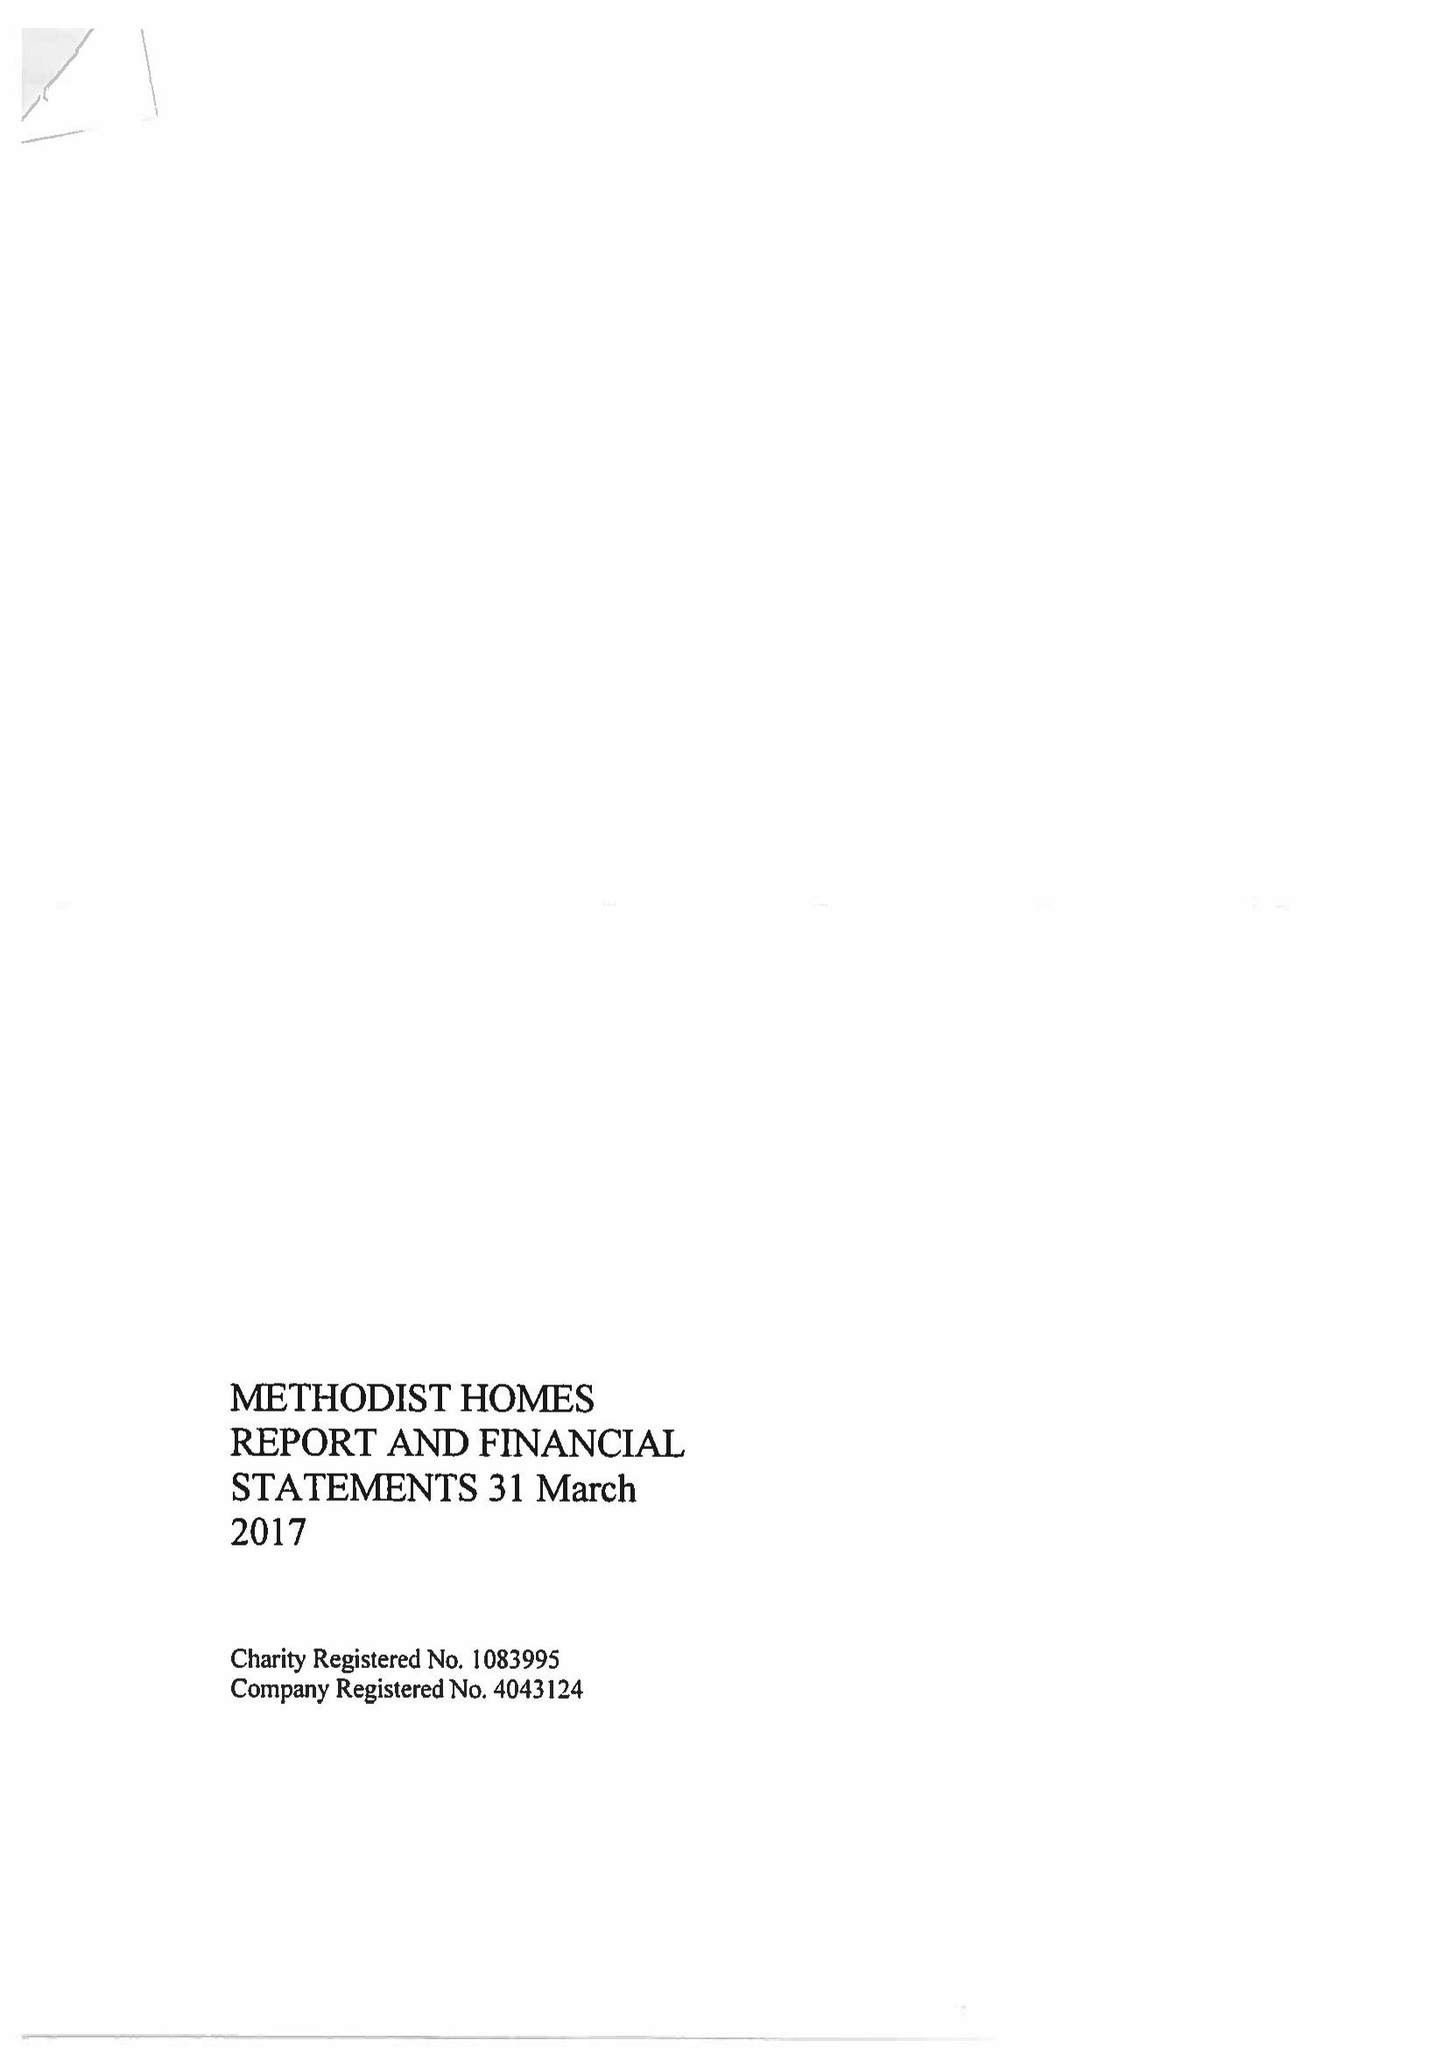What is the value for the charity_number?
Answer the question using a single word or phrase. 1083995 